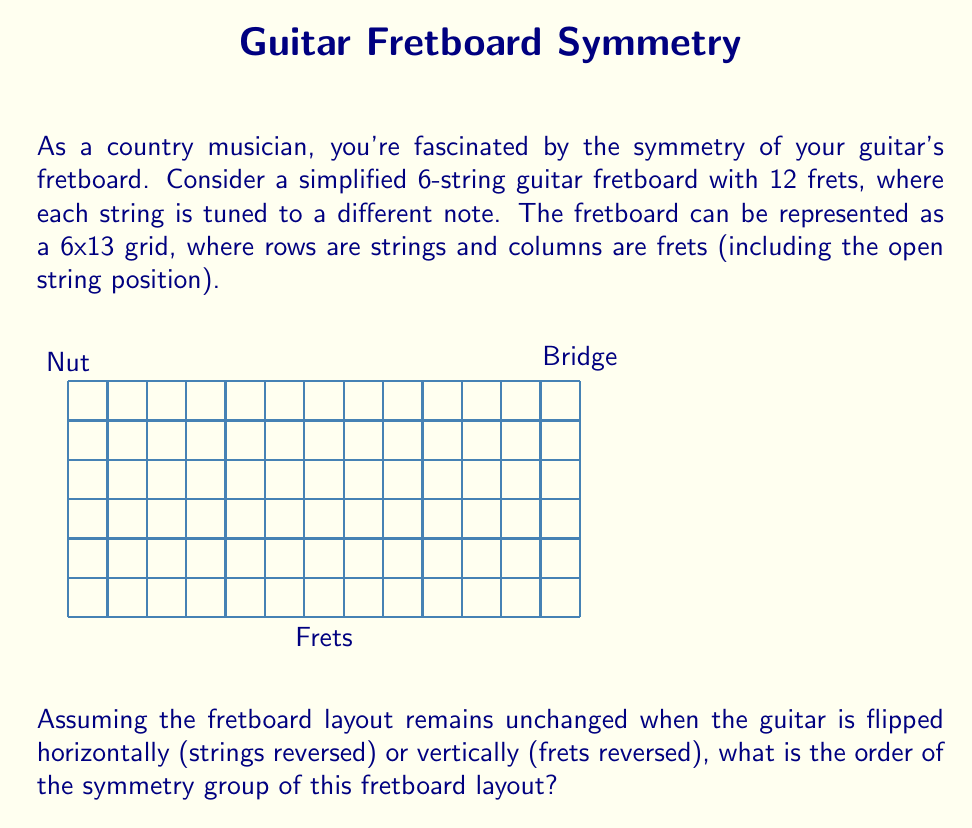Show me your answer to this math problem. Let's approach this step-by-step:

1) First, we need to identify the symmetry operations that leave the fretboard layout unchanged:

   a) Identity (I): Leaving the fretboard as is.
   b) Horizontal flip (H): Reversing the order of strings.
   c) Vertical flip (V): Reversing the order of frets.
   d) 180-degree rotation (R): Equivalent to both flips combined.

2) These operations form a group under composition. Let's verify:

   - $H \circ H = I$, $V \circ V = I$, $R \circ R = I$
   - $H \circ V = R$, $V \circ H = R$
   - $H \circ R = V$, $R \circ H = V$
   - $V \circ R = H$, $R \circ V = H$

3) We can represent this group using the following Cayley table:

   $$
   \begin{array}{c|cccc}
   \circ & I & H & V & R \\
   \hline
   I & I & H & V & R \\
   H & H & I & R & V \\
   V & V & R & I & H \\
   R & R & V & H & I
   \end{array}
   $$

4) This group is isomorphic to the Klein four-group, $V_4$ or $C_2 \times C_2$.

5) The order of a group is the number of elements it contains. In this case, there are 4 elements: $I$, $H$, $V$, and $R$.

Therefore, the order of the symmetry group of the fretboard layout is 4.
Answer: 4 